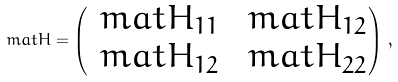<formula> <loc_0><loc_0><loc_500><loc_500>\ m a t { H } = \begin{pmatrix} \ m a t { H } _ { 1 1 } & \ m a t { H } _ { 1 2 } \\ \ m a t { H } _ { 1 2 } & \ m a t { H } _ { 2 2 } \end{pmatrix} \, ,</formula> 